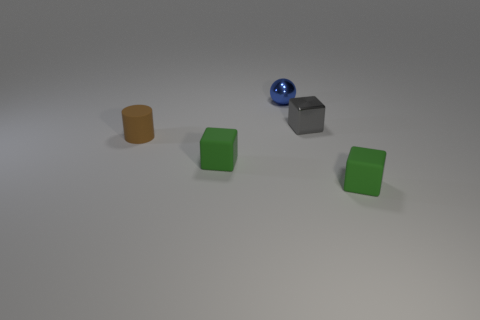There is a cube in front of the green block on the left side of the tiny shiny thing that is in front of the blue metal ball; what is its color?
Keep it short and to the point. Green. What number of objects are small cylinders or blue metallic spheres?
Your answer should be compact. 2. How many green rubber objects are the same shape as the tiny blue metal object?
Offer a very short reply. 0. Do the tiny gray cube and the thing behind the gray metallic cube have the same material?
Your answer should be very brief. Yes. There is a green matte cube that is to the left of the tiny metal ball; what is its size?
Give a very brief answer. Small. What number of objects have the same size as the brown cylinder?
Provide a succinct answer. 4. The metal cube that is the same size as the brown cylinder is what color?
Give a very brief answer. Gray. The tiny metallic ball is what color?
Make the answer very short. Blue. There is a block that is to the right of the metallic cube; what is it made of?
Your answer should be very brief. Rubber. Are there fewer green objects that are to the left of the shiny sphere than blue shiny objects?
Give a very brief answer. No. 